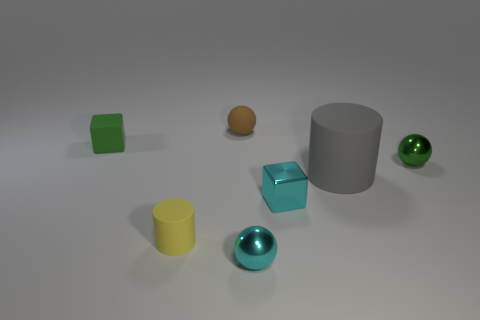Is there any other thing that has the same shape as the big matte thing?
Provide a short and direct response. Yes. What is the color of the small object that is the same shape as the large gray object?
Offer a terse response. Yellow. Does the big cylinder have the same color as the tiny rubber thing that is in front of the green rubber block?
Your answer should be compact. No. There is a matte object that is both to the left of the big thing and on the right side of the yellow cylinder; what shape is it?
Ensure brevity in your answer.  Sphere. Is the number of large cyan objects less than the number of tiny cyan shiny things?
Offer a terse response. Yes. Is there a tiny brown ball?
Your response must be concise. Yes. What number of other things are the same size as the brown ball?
Provide a succinct answer. 5. Is the tiny yellow object made of the same material as the cube left of the tiny yellow matte cylinder?
Offer a very short reply. Yes. Is the number of small cyan cubes that are in front of the small yellow rubber thing the same as the number of tiny green metallic balls that are on the left side of the small rubber sphere?
Keep it short and to the point. Yes. What material is the gray thing?
Your answer should be very brief. Rubber. 